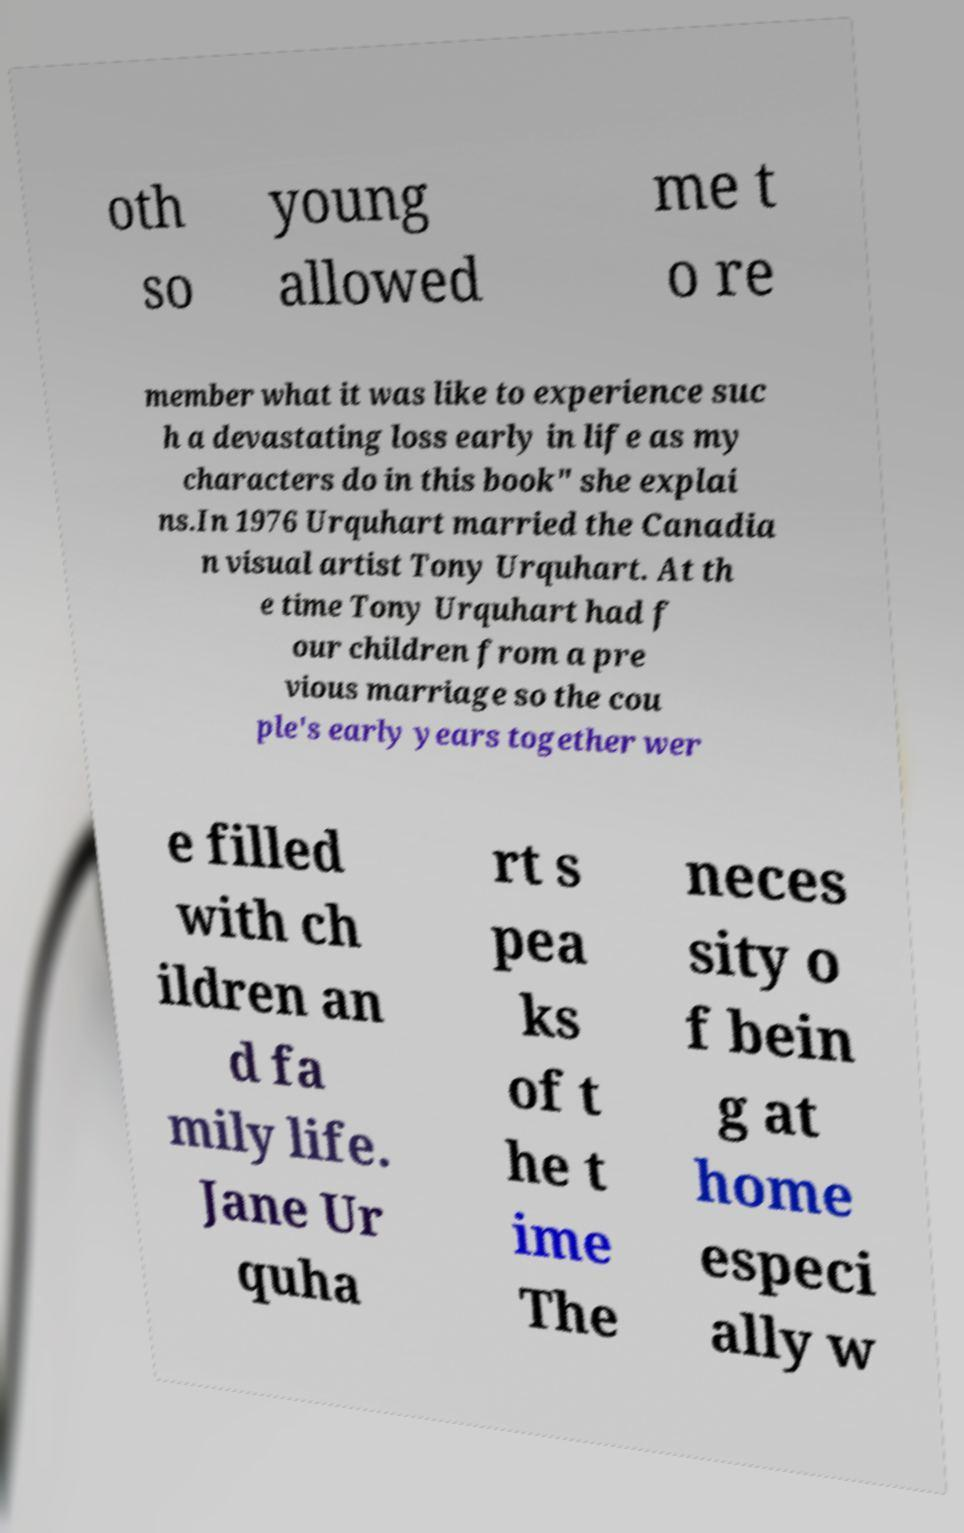There's text embedded in this image that I need extracted. Can you transcribe it verbatim? oth so young allowed me t o re member what it was like to experience suc h a devastating loss early in life as my characters do in this book" she explai ns.In 1976 Urquhart married the Canadia n visual artist Tony Urquhart. At th e time Tony Urquhart had f our children from a pre vious marriage so the cou ple's early years together wer e filled with ch ildren an d fa mily life. Jane Ur quha rt s pea ks of t he t ime The neces sity o f bein g at home especi ally w 